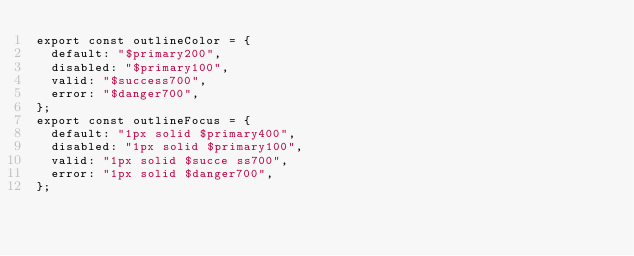Convert code to text. <code><loc_0><loc_0><loc_500><loc_500><_TypeScript_>export const outlineColor = {
  default: "$primary200",
  disabled: "$primary100",
  valid: "$success700",
  error: "$danger700",
};
export const outlineFocus = {
  default: "1px solid $primary400",
  disabled: "1px solid $primary100",
  valid: "1px solid $succe ss700",
  error: "1px solid $danger700",
};
</code> 